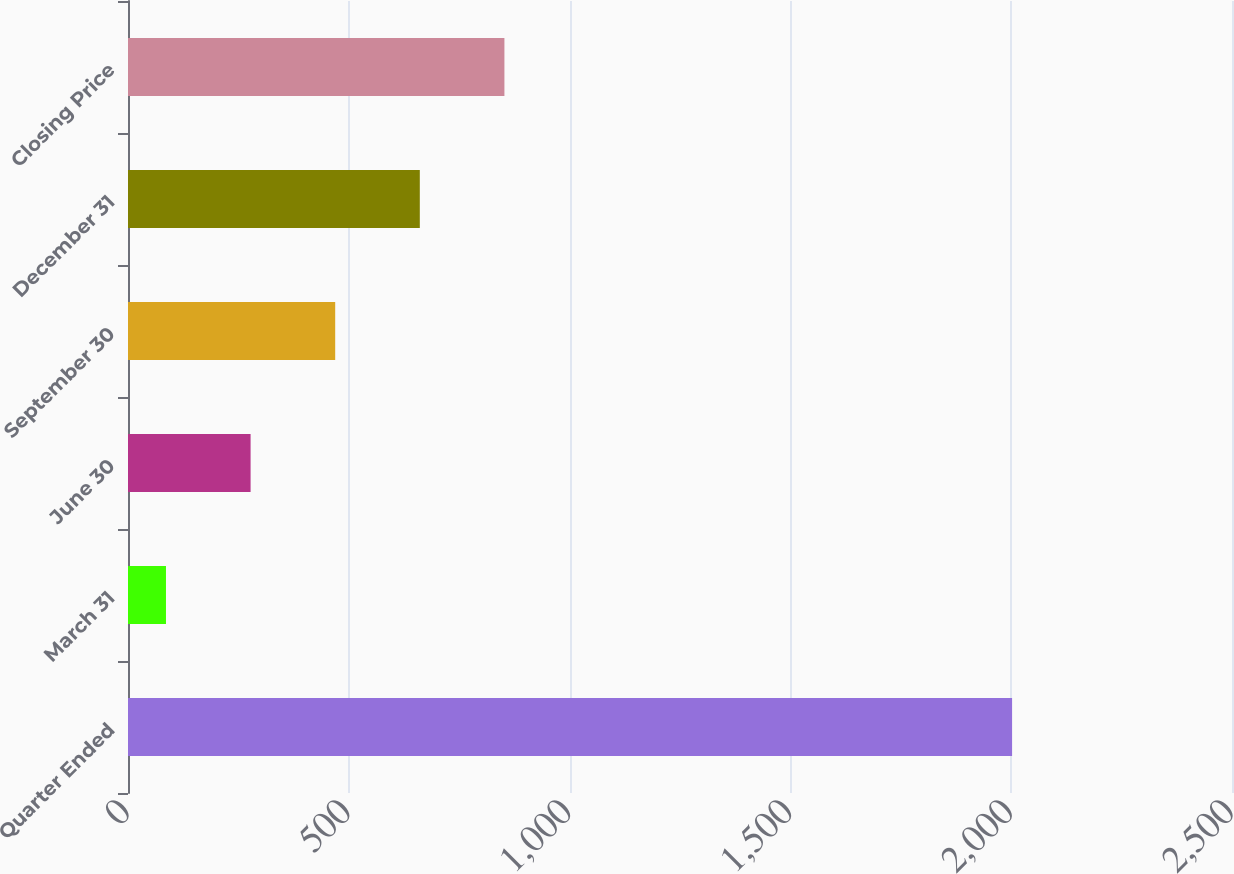Convert chart to OTSL. <chart><loc_0><loc_0><loc_500><loc_500><bar_chart><fcel>Quarter Ended<fcel>March 31<fcel>June 30<fcel>September 30<fcel>December 31<fcel>Closing Price<nl><fcel>2002<fcel>86<fcel>277.6<fcel>469.2<fcel>660.8<fcel>852.4<nl></chart> 